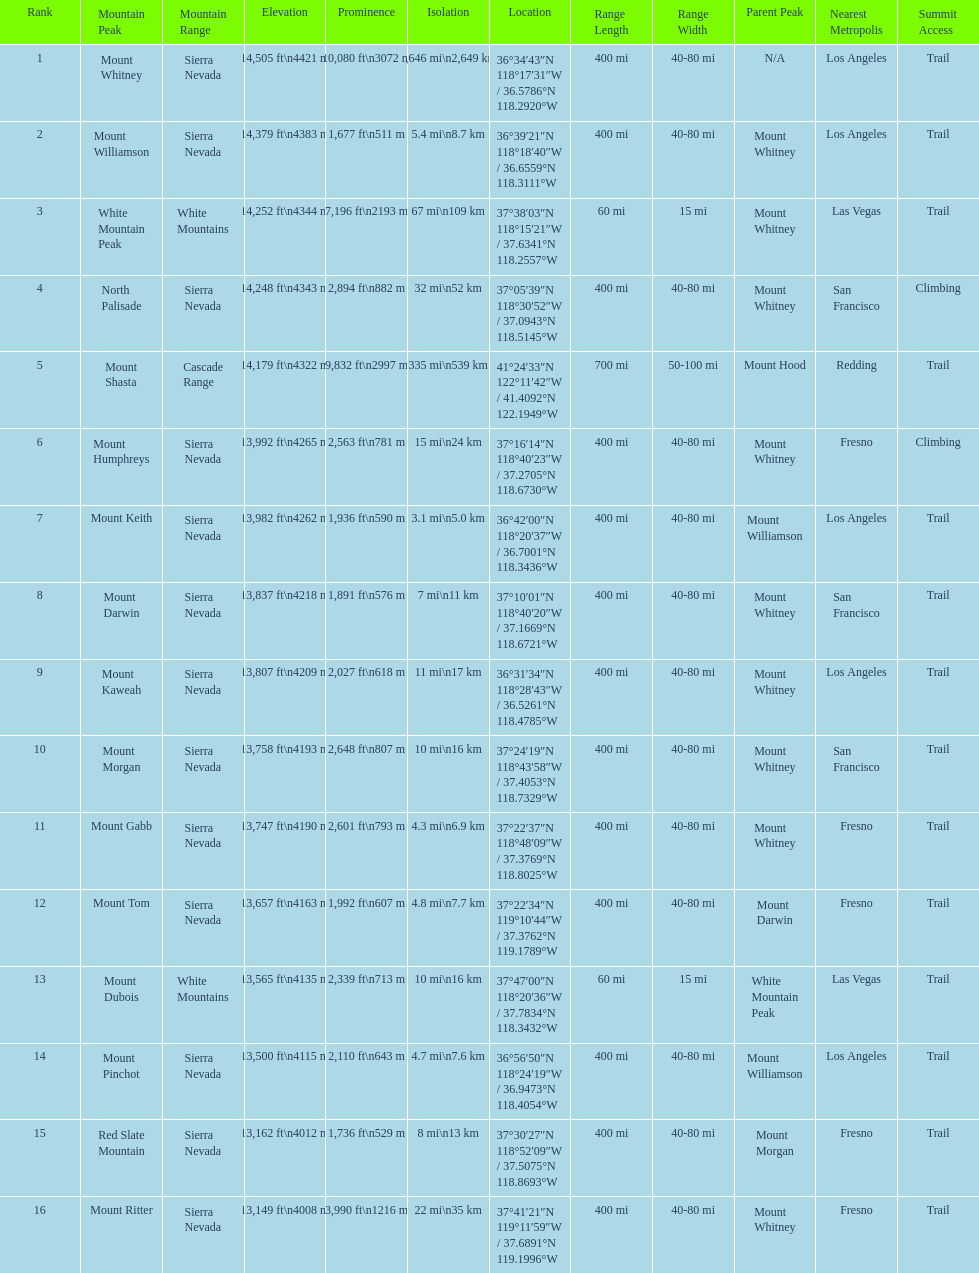What is the next highest mountain peak after north palisade? Mount Shasta. 